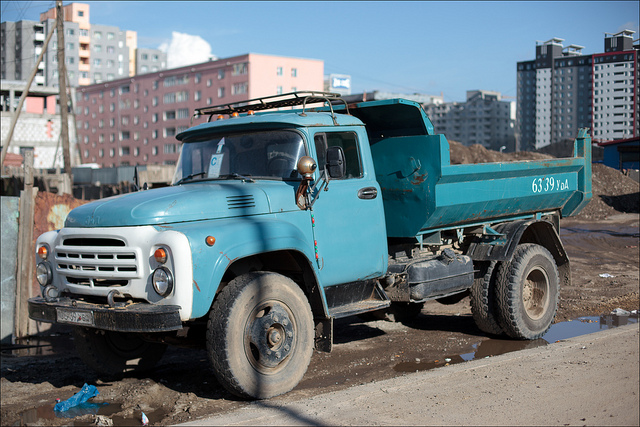<image>What color is the cover of the lorry? I am not sure about the color of the lorry's cover. But it can be seen blue or gray. What color is the cover of the lorry? The cover of the lorry is blue. 